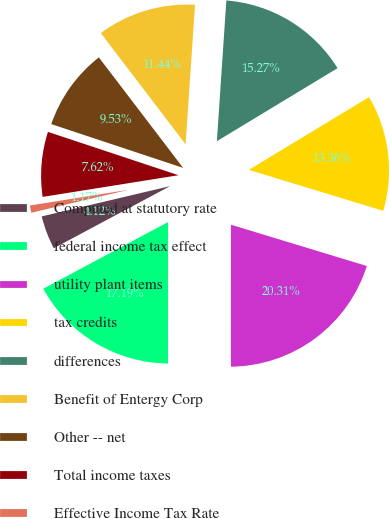Convert chart. <chart><loc_0><loc_0><loc_500><loc_500><pie_chart><fcel>Computed at statutory rate<fcel>federal income tax effect<fcel>utility plant items<fcel>tax credits<fcel>differences<fcel>Benefit of Entergy Corp<fcel>Other -- net<fcel>Total income taxes<fcel>Effective Income Tax Rate<nl><fcel>4.12%<fcel>17.19%<fcel>20.31%<fcel>13.36%<fcel>15.27%<fcel>11.44%<fcel>9.53%<fcel>7.62%<fcel>1.17%<nl></chart> 